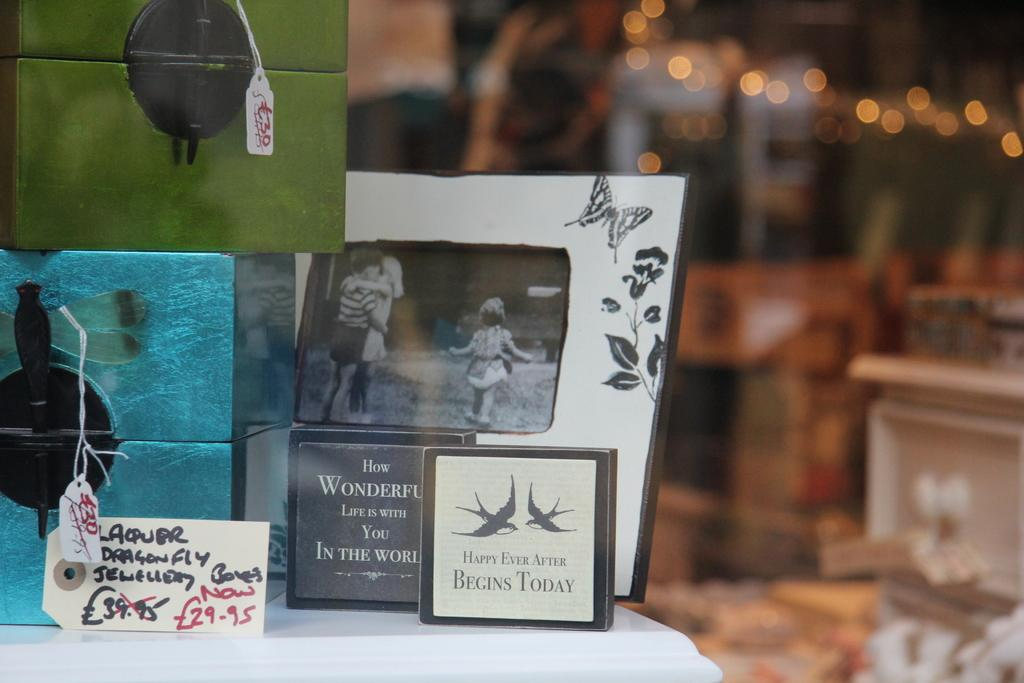What objects are present in the image that are used for displaying photos? There are photo frames in the image. What can be seen on the table in the image? There are boxes on the table in the image. Is there any information about the cost of the box in the image? Yes, the box has a price tag in the image. What type of lighting is visible in the image? There are lightings visible in the image. How would you describe the background of the image? The background of the image is blurred. What type of orange is being used as a degree in the image? There is no orange or degree present in the image. How many bites have been taken out of the box in the image? There is no indication of bites or consumption in the image, as it features photo frames, boxes, and lightings. 